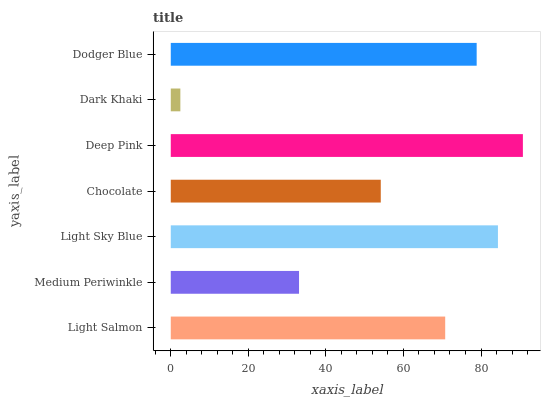Is Dark Khaki the minimum?
Answer yes or no. Yes. Is Deep Pink the maximum?
Answer yes or no. Yes. Is Medium Periwinkle the minimum?
Answer yes or no. No. Is Medium Periwinkle the maximum?
Answer yes or no. No. Is Light Salmon greater than Medium Periwinkle?
Answer yes or no. Yes. Is Medium Periwinkle less than Light Salmon?
Answer yes or no. Yes. Is Medium Periwinkle greater than Light Salmon?
Answer yes or no. No. Is Light Salmon less than Medium Periwinkle?
Answer yes or no. No. Is Light Salmon the high median?
Answer yes or no. Yes. Is Light Salmon the low median?
Answer yes or no. Yes. Is Dark Khaki the high median?
Answer yes or no. No. Is Medium Periwinkle the low median?
Answer yes or no. No. 